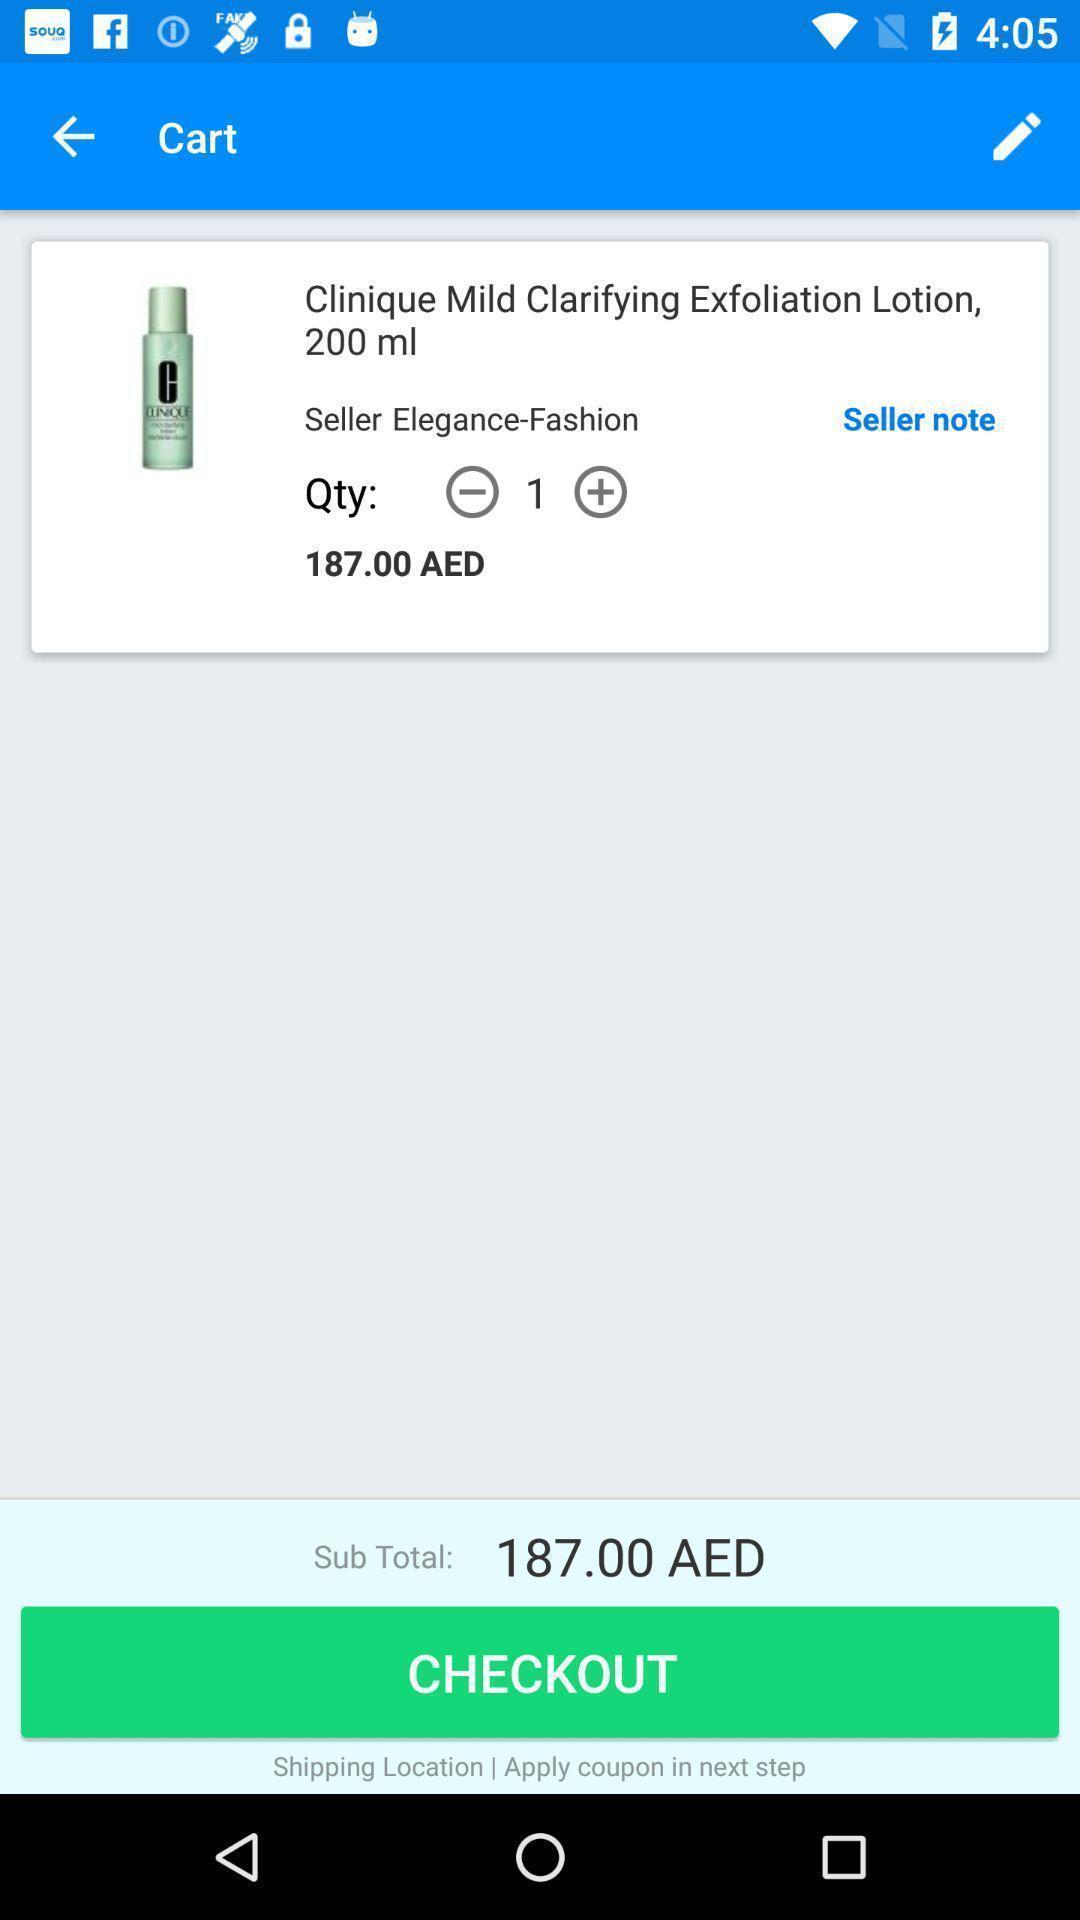Give me a narrative description of this picture. Screen displaying product details with price in a shopping application. 